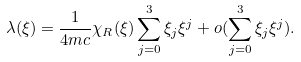<formula> <loc_0><loc_0><loc_500><loc_500>\lambda ( \xi ) = \frac { 1 } { 4 m c } \chi _ { R } ( \xi ) \sum _ { j = 0 } ^ { 3 } \xi _ { j } \xi ^ { j } + o ( \sum _ { j = 0 } ^ { 3 } \xi _ { j } \xi ^ { j } ) .</formula> 